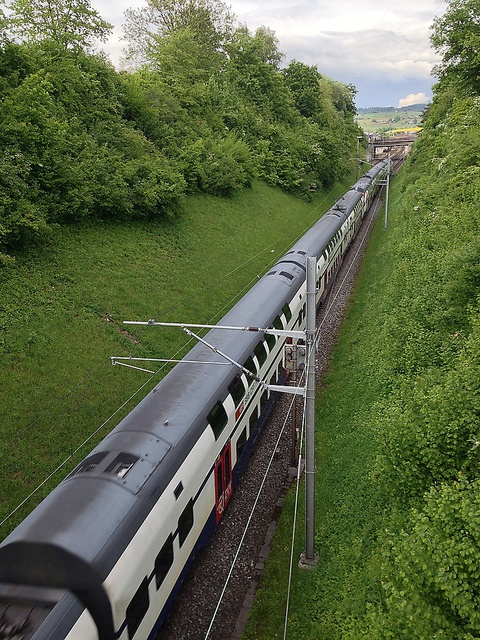Describe the objects in this image and their specific colors. I can see a train in white, darkgray, black, and gray tones in this image. 